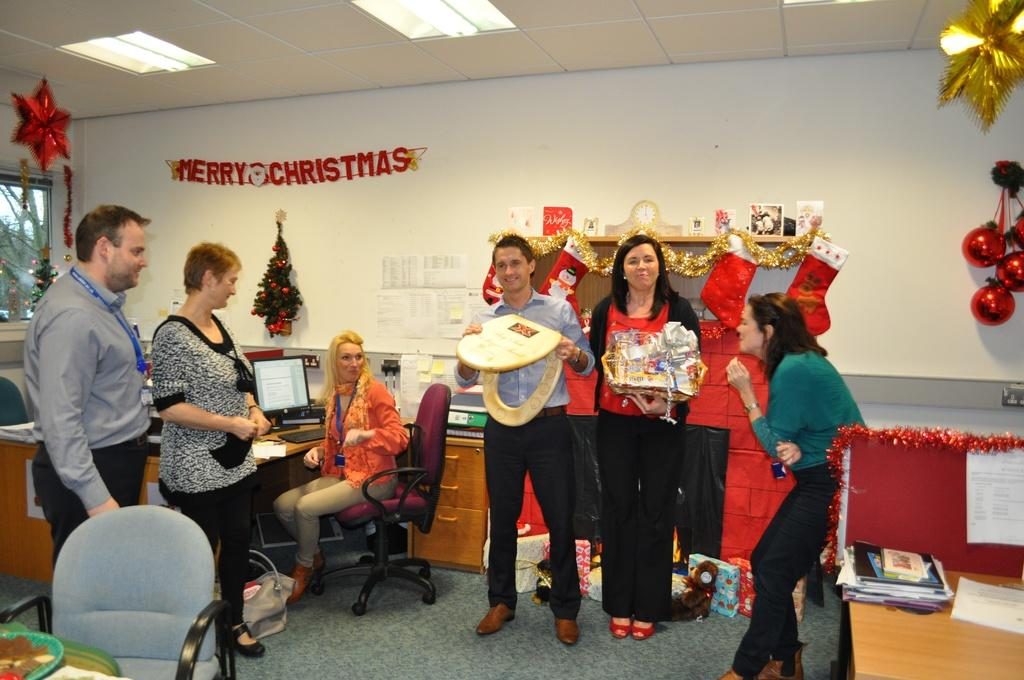How many people are present in the image? There are six people in the image. What are the majority of the people doing in the image? Five of the people are standing, while one person is sitting. What seasonal decoration can be seen in the image? There is a Christmas tree in the image. What type of furniture is present in the image? There is a chair and a desk in the image. What type of patch is being used to apply force to the Christmas tree in the image? There is no patch or force being applied to the Christmas tree in the image; it is simply a decoration. 